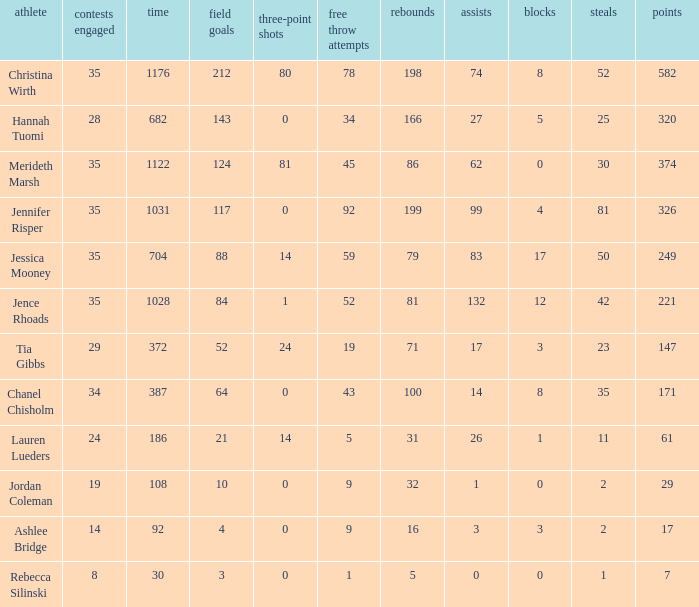For how long did Jordan Coleman play? 108.0. 